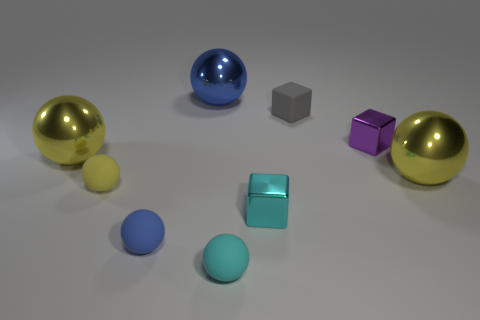How many things are yellow matte spheres or matte spheres that are in front of the tiny cyan metallic cube?
Provide a short and direct response. 3. How many blue things are behind the small metallic object in front of the big yellow sphere to the left of the gray rubber thing?
Your answer should be compact. 1. What is the color of the tiny block that is the same material as the small yellow thing?
Your answer should be compact. Gray. There is a matte ball that is left of the blue rubber ball; is it the same size as the blue matte ball?
Offer a terse response. Yes. How many things are either large shiny objects or matte spheres?
Offer a very short reply. 6. There is a blue object in front of the blue thing that is behind the cube in front of the small yellow rubber ball; what is it made of?
Keep it short and to the point. Rubber. There is a small ball behind the small cyan metal object; what is its material?
Your answer should be very brief. Rubber. Are there any rubber things of the same size as the purple shiny block?
Offer a terse response. Yes. There is a metallic sphere right of the small matte cube; is its color the same as the tiny rubber block?
Offer a terse response. No. How many gray things are cylinders or tiny blocks?
Your answer should be very brief. 1. 